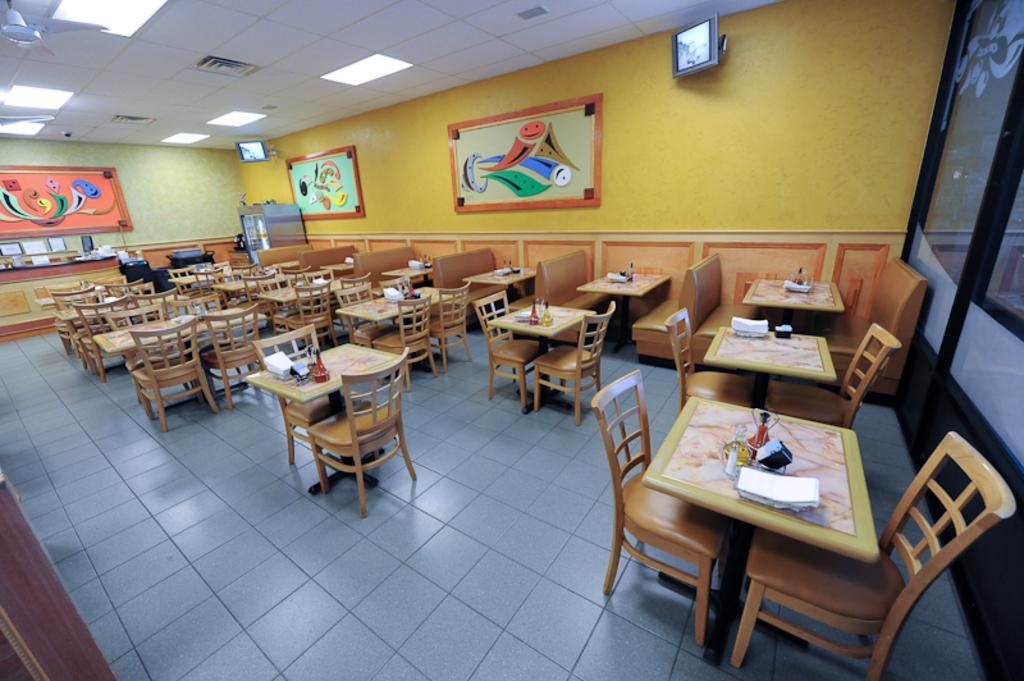Describe this image in one or two sentences. In this image we can see inside of a store. There are many tables and chairs. There are few photos on the wall. There are few objects on the tables. We can see few televisions on the wall. There is a fan at the left side of the image. We can see the lights in the image. 